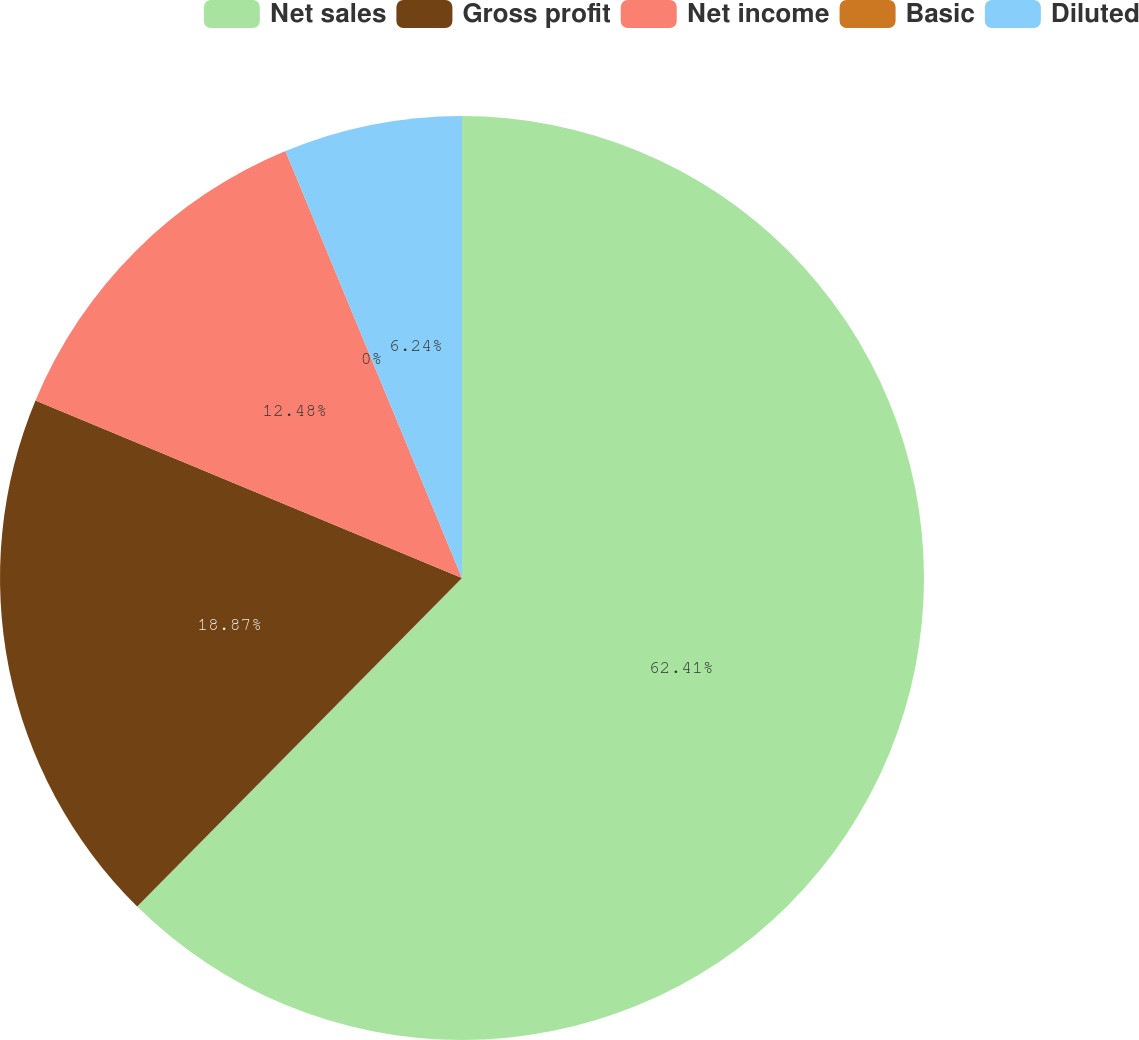<chart> <loc_0><loc_0><loc_500><loc_500><pie_chart><fcel>Net sales<fcel>Gross profit<fcel>Net income<fcel>Basic<fcel>Diluted<nl><fcel>62.41%<fcel>18.87%<fcel>12.48%<fcel>0.0%<fcel>6.24%<nl></chart> 